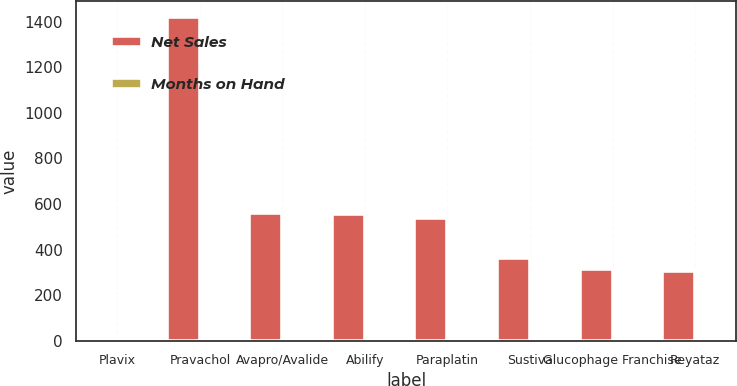<chart> <loc_0><loc_0><loc_500><loc_500><stacked_bar_chart><ecel><fcel>Plavix<fcel>Pravachol<fcel>Avapro/Avalide<fcel>Abilify<fcel>Paraplatin<fcel>Sustiva<fcel>Glucophage Franchise<fcel>Reyataz<nl><fcel>Net Sales<fcel>1.2<fcel>1420<fcel>562<fcel>554<fcel>537<fcel>364<fcel>315<fcel>305<nl><fcel>Months on Hand<fcel>0.8<fcel>0.8<fcel>0.7<fcel>0.7<fcel>1.2<fcel>0.6<fcel>0.9<fcel>0.6<nl></chart> 